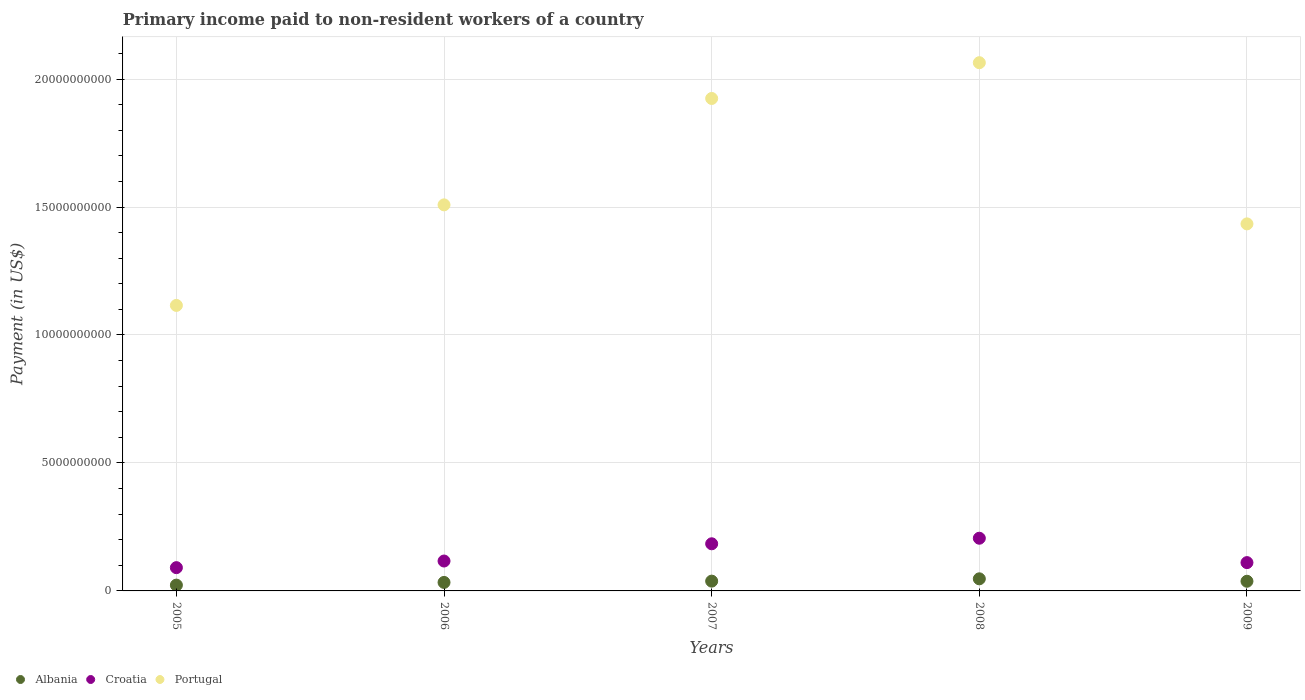How many different coloured dotlines are there?
Provide a short and direct response. 3. Is the number of dotlines equal to the number of legend labels?
Your response must be concise. Yes. What is the amount paid to workers in Albania in 2008?
Keep it short and to the point. 4.73e+08. Across all years, what is the maximum amount paid to workers in Portugal?
Keep it short and to the point. 2.06e+1. Across all years, what is the minimum amount paid to workers in Albania?
Provide a short and direct response. 2.27e+08. In which year was the amount paid to workers in Albania maximum?
Your answer should be compact. 2008. In which year was the amount paid to workers in Croatia minimum?
Your answer should be compact. 2005. What is the total amount paid to workers in Albania in the graph?
Your answer should be compact. 1.79e+09. What is the difference between the amount paid to workers in Albania in 2007 and that in 2009?
Make the answer very short. 5.05e+06. What is the difference between the amount paid to workers in Portugal in 2005 and the amount paid to workers in Albania in 2008?
Offer a very short reply. 1.07e+1. What is the average amount paid to workers in Albania per year?
Keep it short and to the point. 3.58e+08. In the year 2006, what is the difference between the amount paid to workers in Albania and amount paid to workers in Portugal?
Ensure brevity in your answer.  -1.48e+1. In how many years, is the amount paid to workers in Portugal greater than 14000000000 US$?
Provide a succinct answer. 4. What is the ratio of the amount paid to workers in Croatia in 2005 to that in 2006?
Provide a succinct answer. 0.78. Is the difference between the amount paid to workers in Albania in 2006 and 2009 greater than the difference between the amount paid to workers in Portugal in 2006 and 2009?
Keep it short and to the point. No. What is the difference between the highest and the second highest amount paid to workers in Albania?
Ensure brevity in your answer.  9.05e+07. What is the difference between the highest and the lowest amount paid to workers in Portugal?
Provide a short and direct response. 9.48e+09. In how many years, is the amount paid to workers in Croatia greater than the average amount paid to workers in Croatia taken over all years?
Ensure brevity in your answer.  2. Is it the case that in every year, the sum of the amount paid to workers in Portugal and amount paid to workers in Albania  is greater than the amount paid to workers in Croatia?
Your answer should be compact. Yes. What is the difference between two consecutive major ticks on the Y-axis?
Your response must be concise. 5.00e+09. Are the values on the major ticks of Y-axis written in scientific E-notation?
Give a very brief answer. No. Does the graph contain any zero values?
Provide a succinct answer. No. How many legend labels are there?
Make the answer very short. 3. How are the legend labels stacked?
Make the answer very short. Horizontal. What is the title of the graph?
Offer a terse response. Primary income paid to non-resident workers of a country. What is the label or title of the Y-axis?
Your answer should be very brief. Payment (in US$). What is the Payment (in US$) of Albania in 2005?
Your response must be concise. 2.27e+08. What is the Payment (in US$) of Croatia in 2005?
Provide a succinct answer. 9.09e+08. What is the Payment (in US$) in Portugal in 2005?
Give a very brief answer. 1.12e+1. What is the Payment (in US$) of Albania in 2006?
Offer a terse response. 3.32e+08. What is the Payment (in US$) of Croatia in 2006?
Your answer should be compact. 1.17e+09. What is the Payment (in US$) in Portugal in 2006?
Ensure brevity in your answer.  1.51e+1. What is the Payment (in US$) of Albania in 2007?
Ensure brevity in your answer.  3.82e+08. What is the Payment (in US$) in Croatia in 2007?
Your answer should be very brief. 1.84e+09. What is the Payment (in US$) in Portugal in 2007?
Your response must be concise. 1.92e+1. What is the Payment (in US$) of Albania in 2008?
Ensure brevity in your answer.  4.73e+08. What is the Payment (in US$) in Croatia in 2008?
Offer a terse response. 2.06e+09. What is the Payment (in US$) in Portugal in 2008?
Ensure brevity in your answer.  2.06e+1. What is the Payment (in US$) in Albania in 2009?
Your response must be concise. 3.77e+08. What is the Payment (in US$) of Croatia in 2009?
Provide a short and direct response. 1.11e+09. What is the Payment (in US$) of Portugal in 2009?
Offer a very short reply. 1.43e+1. Across all years, what is the maximum Payment (in US$) in Albania?
Make the answer very short. 4.73e+08. Across all years, what is the maximum Payment (in US$) of Croatia?
Your answer should be compact. 2.06e+09. Across all years, what is the maximum Payment (in US$) in Portugal?
Give a very brief answer. 2.06e+1. Across all years, what is the minimum Payment (in US$) of Albania?
Provide a succinct answer. 2.27e+08. Across all years, what is the minimum Payment (in US$) of Croatia?
Keep it short and to the point. 9.09e+08. Across all years, what is the minimum Payment (in US$) in Portugal?
Provide a succinct answer. 1.12e+1. What is the total Payment (in US$) in Albania in the graph?
Keep it short and to the point. 1.79e+09. What is the total Payment (in US$) in Croatia in the graph?
Ensure brevity in your answer.  7.08e+09. What is the total Payment (in US$) in Portugal in the graph?
Offer a very short reply. 8.05e+1. What is the difference between the Payment (in US$) of Albania in 2005 and that in 2006?
Offer a very short reply. -1.05e+08. What is the difference between the Payment (in US$) of Croatia in 2005 and that in 2006?
Keep it short and to the point. -2.59e+08. What is the difference between the Payment (in US$) of Portugal in 2005 and that in 2006?
Keep it short and to the point. -3.93e+09. What is the difference between the Payment (in US$) in Albania in 2005 and that in 2007?
Give a very brief answer. -1.56e+08. What is the difference between the Payment (in US$) of Croatia in 2005 and that in 2007?
Your answer should be compact. -9.33e+08. What is the difference between the Payment (in US$) in Portugal in 2005 and that in 2007?
Provide a short and direct response. -8.09e+09. What is the difference between the Payment (in US$) of Albania in 2005 and that in 2008?
Your answer should be very brief. -2.46e+08. What is the difference between the Payment (in US$) of Croatia in 2005 and that in 2008?
Offer a terse response. -1.15e+09. What is the difference between the Payment (in US$) in Portugal in 2005 and that in 2008?
Keep it short and to the point. -9.48e+09. What is the difference between the Payment (in US$) in Albania in 2005 and that in 2009?
Offer a terse response. -1.51e+08. What is the difference between the Payment (in US$) in Croatia in 2005 and that in 2009?
Offer a very short reply. -1.97e+08. What is the difference between the Payment (in US$) of Portugal in 2005 and that in 2009?
Your answer should be compact. -3.19e+09. What is the difference between the Payment (in US$) of Albania in 2006 and that in 2007?
Offer a very short reply. -5.03e+07. What is the difference between the Payment (in US$) in Croatia in 2006 and that in 2007?
Give a very brief answer. -6.74e+08. What is the difference between the Payment (in US$) of Portugal in 2006 and that in 2007?
Give a very brief answer. -4.16e+09. What is the difference between the Payment (in US$) in Albania in 2006 and that in 2008?
Provide a short and direct response. -1.41e+08. What is the difference between the Payment (in US$) in Croatia in 2006 and that in 2008?
Ensure brevity in your answer.  -8.91e+08. What is the difference between the Payment (in US$) in Portugal in 2006 and that in 2008?
Provide a short and direct response. -5.55e+09. What is the difference between the Payment (in US$) in Albania in 2006 and that in 2009?
Give a very brief answer. -4.53e+07. What is the difference between the Payment (in US$) in Croatia in 2006 and that in 2009?
Your answer should be compact. 6.18e+07. What is the difference between the Payment (in US$) in Portugal in 2006 and that in 2009?
Give a very brief answer. 7.43e+08. What is the difference between the Payment (in US$) of Albania in 2007 and that in 2008?
Your answer should be very brief. -9.05e+07. What is the difference between the Payment (in US$) of Croatia in 2007 and that in 2008?
Your answer should be very brief. -2.17e+08. What is the difference between the Payment (in US$) of Portugal in 2007 and that in 2008?
Provide a succinct answer. -1.40e+09. What is the difference between the Payment (in US$) in Albania in 2007 and that in 2009?
Your answer should be very brief. 5.05e+06. What is the difference between the Payment (in US$) of Croatia in 2007 and that in 2009?
Your answer should be very brief. 7.36e+08. What is the difference between the Payment (in US$) of Portugal in 2007 and that in 2009?
Ensure brevity in your answer.  4.90e+09. What is the difference between the Payment (in US$) in Albania in 2008 and that in 2009?
Ensure brevity in your answer.  9.55e+07. What is the difference between the Payment (in US$) of Croatia in 2008 and that in 2009?
Your response must be concise. 9.53e+08. What is the difference between the Payment (in US$) in Portugal in 2008 and that in 2009?
Your answer should be very brief. 6.30e+09. What is the difference between the Payment (in US$) in Albania in 2005 and the Payment (in US$) in Croatia in 2006?
Keep it short and to the point. -9.41e+08. What is the difference between the Payment (in US$) of Albania in 2005 and the Payment (in US$) of Portugal in 2006?
Your answer should be very brief. -1.49e+1. What is the difference between the Payment (in US$) in Croatia in 2005 and the Payment (in US$) in Portugal in 2006?
Your answer should be very brief. -1.42e+1. What is the difference between the Payment (in US$) of Albania in 2005 and the Payment (in US$) of Croatia in 2007?
Ensure brevity in your answer.  -1.62e+09. What is the difference between the Payment (in US$) in Albania in 2005 and the Payment (in US$) in Portugal in 2007?
Offer a terse response. -1.90e+1. What is the difference between the Payment (in US$) of Croatia in 2005 and the Payment (in US$) of Portugal in 2007?
Keep it short and to the point. -1.83e+1. What is the difference between the Payment (in US$) in Albania in 2005 and the Payment (in US$) in Croatia in 2008?
Offer a very short reply. -1.83e+09. What is the difference between the Payment (in US$) of Albania in 2005 and the Payment (in US$) of Portugal in 2008?
Give a very brief answer. -2.04e+1. What is the difference between the Payment (in US$) in Croatia in 2005 and the Payment (in US$) in Portugal in 2008?
Keep it short and to the point. -1.97e+1. What is the difference between the Payment (in US$) in Albania in 2005 and the Payment (in US$) in Croatia in 2009?
Keep it short and to the point. -8.80e+08. What is the difference between the Payment (in US$) in Albania in 2005 and the Payment (in US$) in Portugal in 2009?
Your answer should be compact. -1.41e+1. What is the difference between the Payment (in US$) in Croatia in 2005 and the Payment (in US$) in Portugal in 2009?
Your response must be concise. -1.34e+1. What is the difference between the Payment (in US$) of Albania in 2006 and the Payment (in US$) of Croatia in 2007?
Keep it short and to the point. -1.51e+09. What is the difference between the Payment (in US$) of Albania in 2006 and the Payment (in US$) of Portugal in 2007?
Make the answer very short. -1.89e+1. What is the difference between the Payment (in US$) in Croatia in 2006 and the Payment (in US$) in Portugal in 2007?
Provide a succinct answer. -1.81e+1. What is the difference between the Payment (in US$) in Albania in 2006 and the Payment (in US$) in Croatia in 2008?
Ensure brevity in your answer.  -1.73e+09. What is the difference between the Payment (in US$) in Albania in 2006 and the Payment (in US$) in Portugal in 2008?
Make the answer very short. -2.03e+1. What is the difference between the Payment (in US$) of Croatia in 2006 and the Payment (in US$) of Portugal in 2008?
Give a very brief answer. -1.95e+1. What is the difference between the Payment (in US$) of Albania in 2006 and the Payment (in US$) of Croatia in 2009?
Ensure brevity in your answer.  -7.74e+08. What is the difference between the Payment (in US$) in Albania in 2006 and the Payment (in US$) in Portugal in 2009?
Provide a succinct answer. -1.40e+1. What is the difference between the Payment (in US$) of Croatia in 2006 and the Payment (in US$) of Portugal in 2009?
Offer a terse response. -1.32e+1. What is the difference between the Payment (in US$) of Albania in 2007 and the Payment (in US$) of Croatia in 2008?
Make the answer very short. -1.68e+09. What is the difference between the Payment (in US$) of Albania in 2007 and the Payment (in US$) of Portugal in 2008?
Your answer should be very brief. -2.03e+1. What is the difference between the Payment (in US$) in Croatia in 2007 and the Payment (in US$) in Portugal in 2008?
Keep it short and to the point. -1.88e+1. What is the difference between the Payment (in US$) in Albania in 2007 and the Payment (in US$) in Croatia in 2009?
Give a very brief answer. -7.24e+08. What is the difference between the Payment (in US$) of Albania in 2007 and the Payment (in US$) of Portugal in 2009?
Give a very brief answer. -1.40e+1. What is the difference between the Payment (in US$) in Croatia in 2007 and the Payment (in US$) in Portugal in 2009?
Ensure brevity in your answer.  -1.25e+1. What is the difference between the Payment (in US$) of Albania in 2008 and the Payment (in US$) of Croatia in 2009?
Provide a short and direct response. -6.33e+08. What is the difference between the Payment (in US$) in Albania in 2008 and the Payment (in US$) in Portugal in 2009?
Provide a short and direct response. -1.39e+1. What is the difference between the Payment (in US$) of Croatia in 2008 and the Payment (in US$) of Portugal in 2009?
Give a very brief answer. -1.23e+1. What is the average Payment (in US$) of Albania per year?
Your answer should be very brief. 3.58e+08. What is the average Payment (in US$) of Croatia per year?
Make the answer very short. 1.42e+09. What is the average Payment (in US$) of Portugal per year?
Your answer should be compact. 1.61e+1. In the year 2005, what is the difference between the Payment (in US$) in Albania and Payment (in US$) in Croatia?
Your response must be concise. -6.83e+08. In the year 2005, what is the difference between the Payment (in US$) in Albania and Payment (in US$) in Portugal?
Offer a very short reply. -1.09e+1. In the year 2005, what is the difference between the Payment (in US$) of Croatia and Payment (in US$) of Portugal?
Offer a terse response. -1.02e+1. In the year 2006, what is the difference between the Payment (in US$) in Albania and Payment (in US$) in Croatia?
Offer a very short reply. -8.36e+08. In the year 2006, what is the difference between the Payment (in US$) in Albania and Payment (in US$) in Portugal?
Offer a very short reply. -1.48e+1. In the year 2006, what is the difference between the Payment (in US$) of Croatia and Payment (in US$) of Portugal?
Provide a succinct answer. -1.39e+1. In the year 2007, what is the difference between the Payment (in US$) of Albania and Payment (in US$) of Croatia?
Make the answer very short. -1.46e+09. In the year 2007, what is the difference between the Payment (in US$) in Albania and Payment (in US$) in Portugal?
Give a very brief answer. -1.89e+1. In the year 2007, what is the difference between the Payment (in US$) in Croatia and Payment (in US$) in Portugal?
Ensure brevity in your answer.  -1.74e+1. In the year 2008, what is the difference between the Payment (in US$) in Albania and Payment (in US$) in Croatia?
Ensure brevity in your answer.  -1.59e+09. In the year 2008, what is the difference between the Payment (in US$) in Albania and Payment (in US$) in Portugal?
Your response must be concise. -2.02e+1. In the year 2008, what is the difference between the Payment (in US$) in Croatia and Payment (in US$) in Portugal?
Ensure brevity in your answer.  -1.86e+1. In the year 2009, what is the difference between the Payment (in US$) of Albania and Payment (in US$) of Croatia?
Your answer should be compact. -7.29e+08. In the year 2009, what is the difference between the Payment (in US$) in Albania and Payment (in US$) in Portugal?
Ensure brevity in your answer.  -1.40e+1. In the year 2009, what is the difference between the Payment (in US$) of Croatia and Payment (in US$) of Portugal?
Your response must be concise. -1.32e+1. What is the ratio of the Payment (in US$) of Albania in 2005 to that in 2006?
Give a very brief answer. 0.68. What is the ratio of the Payment (in US$) in Croatia in 2005 to that in 2006?
Make the answer very short. 0.78. What is the ratio of the Payment (in US$) of Portugal in 2005 to that in 2006?
Offer a terse response. 0.74. What is the ratio of the Payment (in US$) of Albania in 2005 to that in 2007?
Offer a terse response. 0.59. What is the ratio of the Payment (in US$) of Croatia in 2005 to that in 2007?
Ensure brevity in your answer.  0.49. What is the ratio of the Payment (in US$) in Portugal in 2005 to that in 2007?
Provide a short and direct response. 0.58. What is the ratio of the Payment (in US$) in Albania in 2005 to that in 2008?
Give a very brief answer. 0.48. What is the ratio of the Payment (in US$) of Croatia in 2005 to that in 2008?
Keep it short and to the point. 0.44. What is the ratio of the Payment (in US$) in Portugal in 2005 to that in 2008?
Keep it short and to the point. 0.54. What is the ratio of the Payment (in US$) of Albania in 2005 to that in 2009?
Your answer should be very brief. 0.6. What is the ratio of the Payment (in US$) of Croatia in 2005 to that in 2009?
Keep it short and to the point. 0.82. What is the ratio of the Payment (in US$) of Portugal in 2005 to that in 2009?
Offer a very short reply. 0.78. What is the ratio of the Payment (in US$) in Albania in 2006 to that in 2007?
Give a very brief answer. 0.87. What is the ratio of the Payment (in US$) of Croatia in 2006 to that in 2007?
Ensure brevity in your answer.  0.63. What is the ratio of the Payment (in US$) of Portugal in 2006 to that in 2007?
Offer a very short reply. 0.78. What is the ratio of the Payment (in US$) of Albania in 2006 to that in 2008?
Offer a terse response. 0.7. What is the ratio of the Payment (in US$) of Croatia in 2006 to that in 2008?
Make the answer very short. 0.57. What is the ratio of the Payment (in US$) of Portugal in 2006 to that in 2008?
Give a very brief answer. 0.73. What is the ratio of the Payment (in US$) of Albania in 2006 to that in 2009?
Offer a very short reply. 0.88. What is the ratio of the Payment (in US$) of Croatia in 2006 to that in 2009?
Keep it short and to the point. 1.06. What is the ratio of the Payment (in US$) in Portugal in 2006 to that in 2009?
Offer a very short reply. 1.05. What is the ratio of the Payment (in US$) of Albania in 2007 to that in 2008?
Ensure brevity in your answer.  0.81. What is the ratio of the Payment (in US$) in Croatia in 2007 to that in 2008?
Ensure brevity in your answer.  0.89. What is the ratio of the Payment (in US$) in Portugal in 2007 to that in 2008?
Offer a very short reply. 0.93. What is the ratio of the Payment (in US$) in Albania in 2007 to that in 2009?
Keep it short and to the point. 1.01. What is the ratio of the Payment (in US$) of Croatia in 2007 to that in 2009?
Give a very brief answer. 1.66. What is the ratio of the Payment (in US$) in Portugal in 2007 to that in 2009?
Give a very brief answer. 1.34. What is the ratio of the Payment (in US$) of Albania in 2008 to that in 2009?
Ensure brevity in your answer.  1.25. What is the ratio of the Payment (in US$) of Croatia in 2008 to that in 2009?
Ensure brevity in your answer.  1.86. What is the ratio of the Payment (in US$) in Portugal in 2008 to that in 2009?
Offer a terse response. 1.44. What is the difference between the highest and the second highest Payment (in US$) in Albania?
Offer a terse response. 9.05e+07. What is the difference between the highest and the second highest Payment (in US$) in Croatia?
Give a very brief answer. 2.17e+08. What is the difference between the highest and the second highest Payment (in US$) of Portugal?
Offer a very short reply. 1.40e+09. What is the difference between the highest and the lowest Payment (in US$) in Albania?
Your answer should be compact. 2.46e+08. What is the difference between the highest and the lowest Payment (in US$) of Croatia?
Give a very brief answer. 1.15e+09. What is the difference between the highest and the lowest Payment (in US$) of Portugal?
Provide a succinct answer. 9.48e+09. 